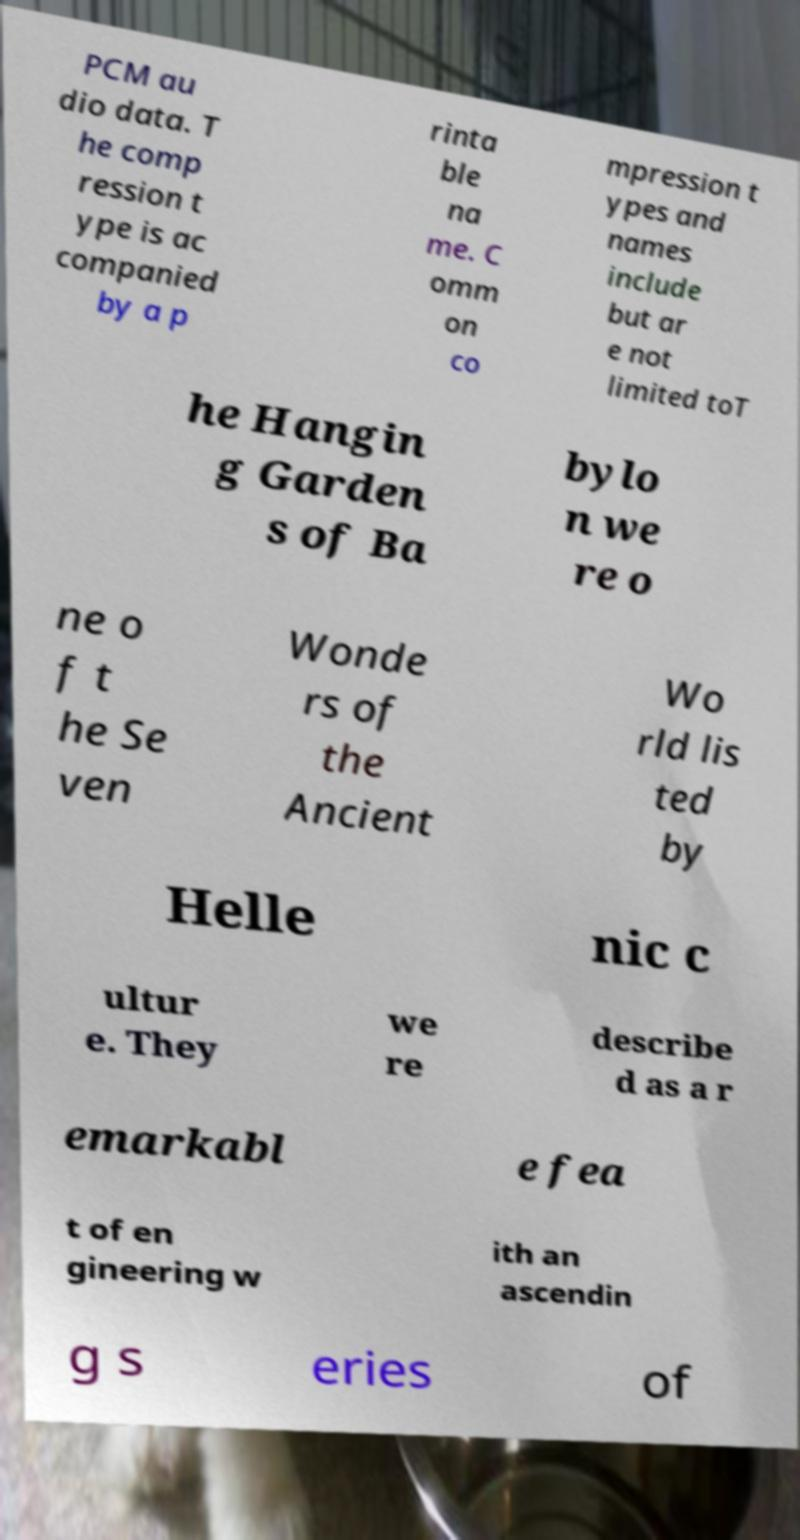Please identify and transcribe the text found in this image. PCM au dio data. T he comp ression t ype is ac companied by a p rinta ble na me. C omm on co mpression t ypes and names include but ar e not limited toT he Hangin g Garden s of Ba bylo n we re o ne o f t he Se ven Wonde rs of the Ancient Wo rld lis ted by Helle nic c ultur e. They we re describe d as a r emarkabl e fea t of en gineering w ith an ascendin g s eries of 